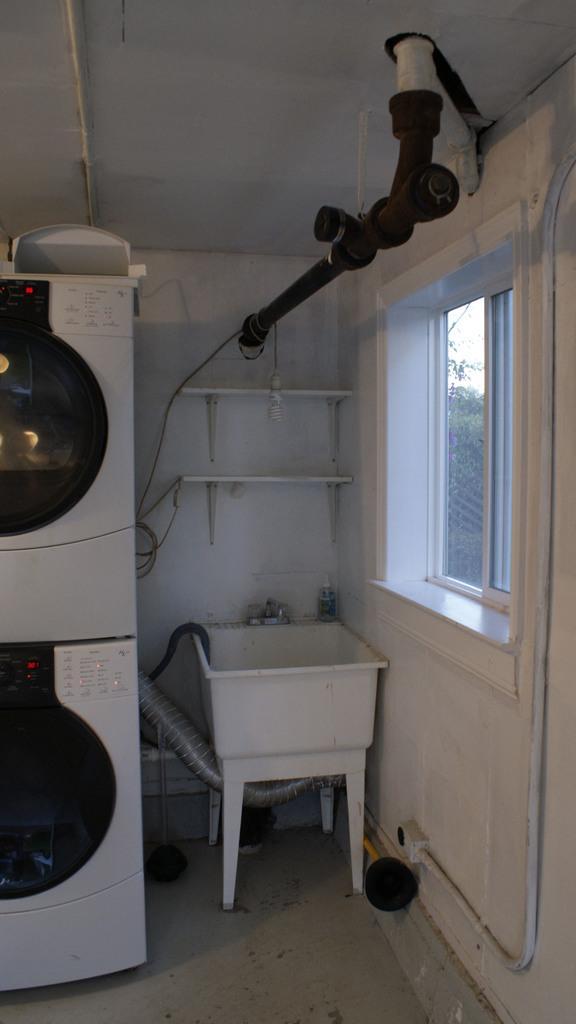Please provide a concise description of this image. This picture is taken inside the room. In this image, on the left side, we can see a refrigerator. In the middle of the image, we can see a tub with some electrical instrument, we can also see a shelf in the middle of the image. On the right side, we can see a glass window, outside of the glass window, we can see some trees. At the top, we can see some electrical instrument and a roof. On the left side, we can also see a pipe. 